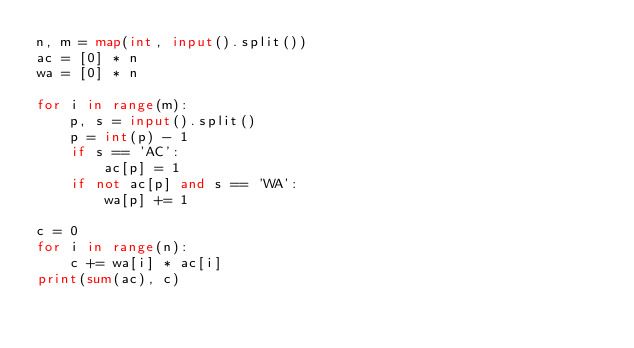<code> <loc_0><loc_0><loc_500><loc_500><_Python_>n, m = map(int, input().split())
ac = [0] * n
wa = [0] * n

for i in range(m):
    p, s = input().split()
    p = int(p) - 1
    if s == 'AC':
        ac[p] = 1
    if not ac[p] and s == 'WA':
        wa[p] += 1

c = 0
for i in range(n):
    c += wa[i] * ac[i]
print(sum(ac), c)
</code> 